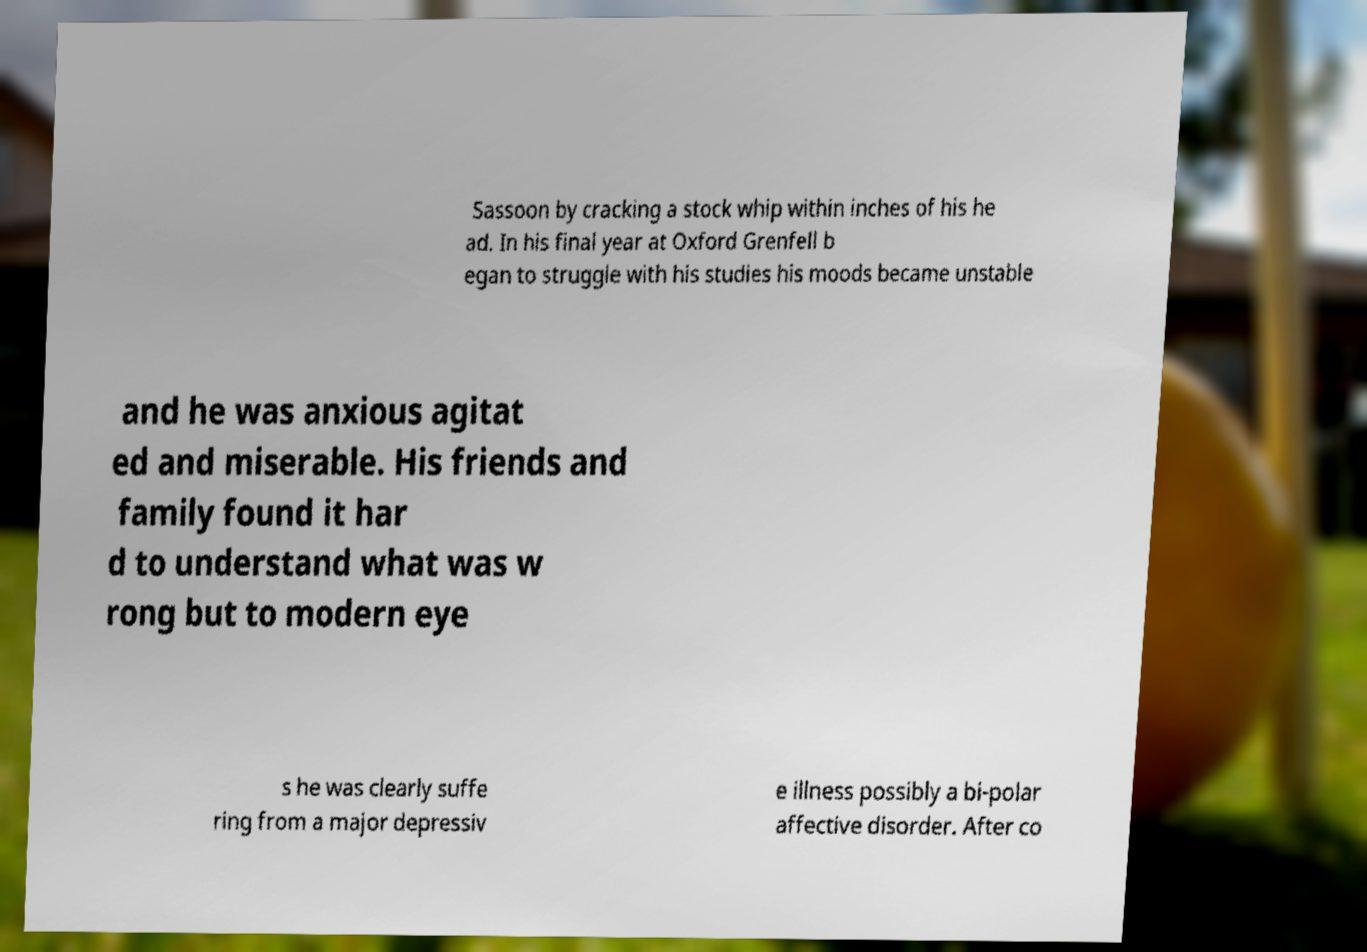For documentation purposes, I need the text within this image transcribed. Could you provide that? Sassoon by cracking a stock whip within inches of his he ad. In his final year at Oxford Grenfell b egan to struggle with his studies his moods became unstable and he was anxious agitat ed and miserable. His friends and family found it har d to understand what was w rong but to modern eye s he was clearly suffe ring from a major depressiv e illness possibly a bi-polar affective disorder. After co 